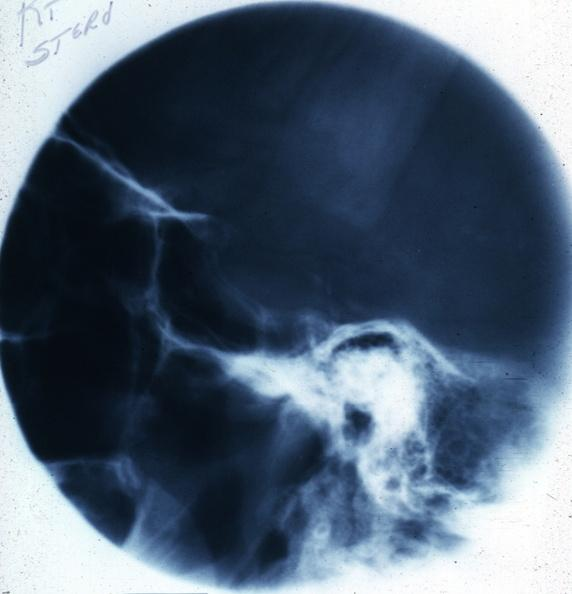what is present?
Answer the question using a single word or phrase. Endocrine 